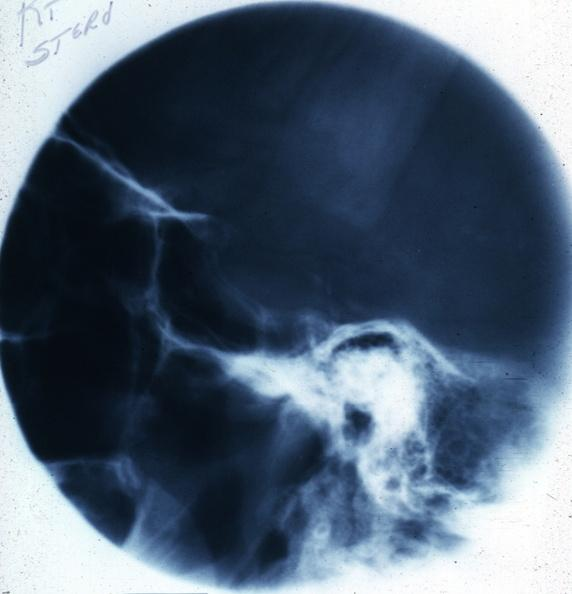what is present?
Answer the question using a single word or phrase. Endocrine 